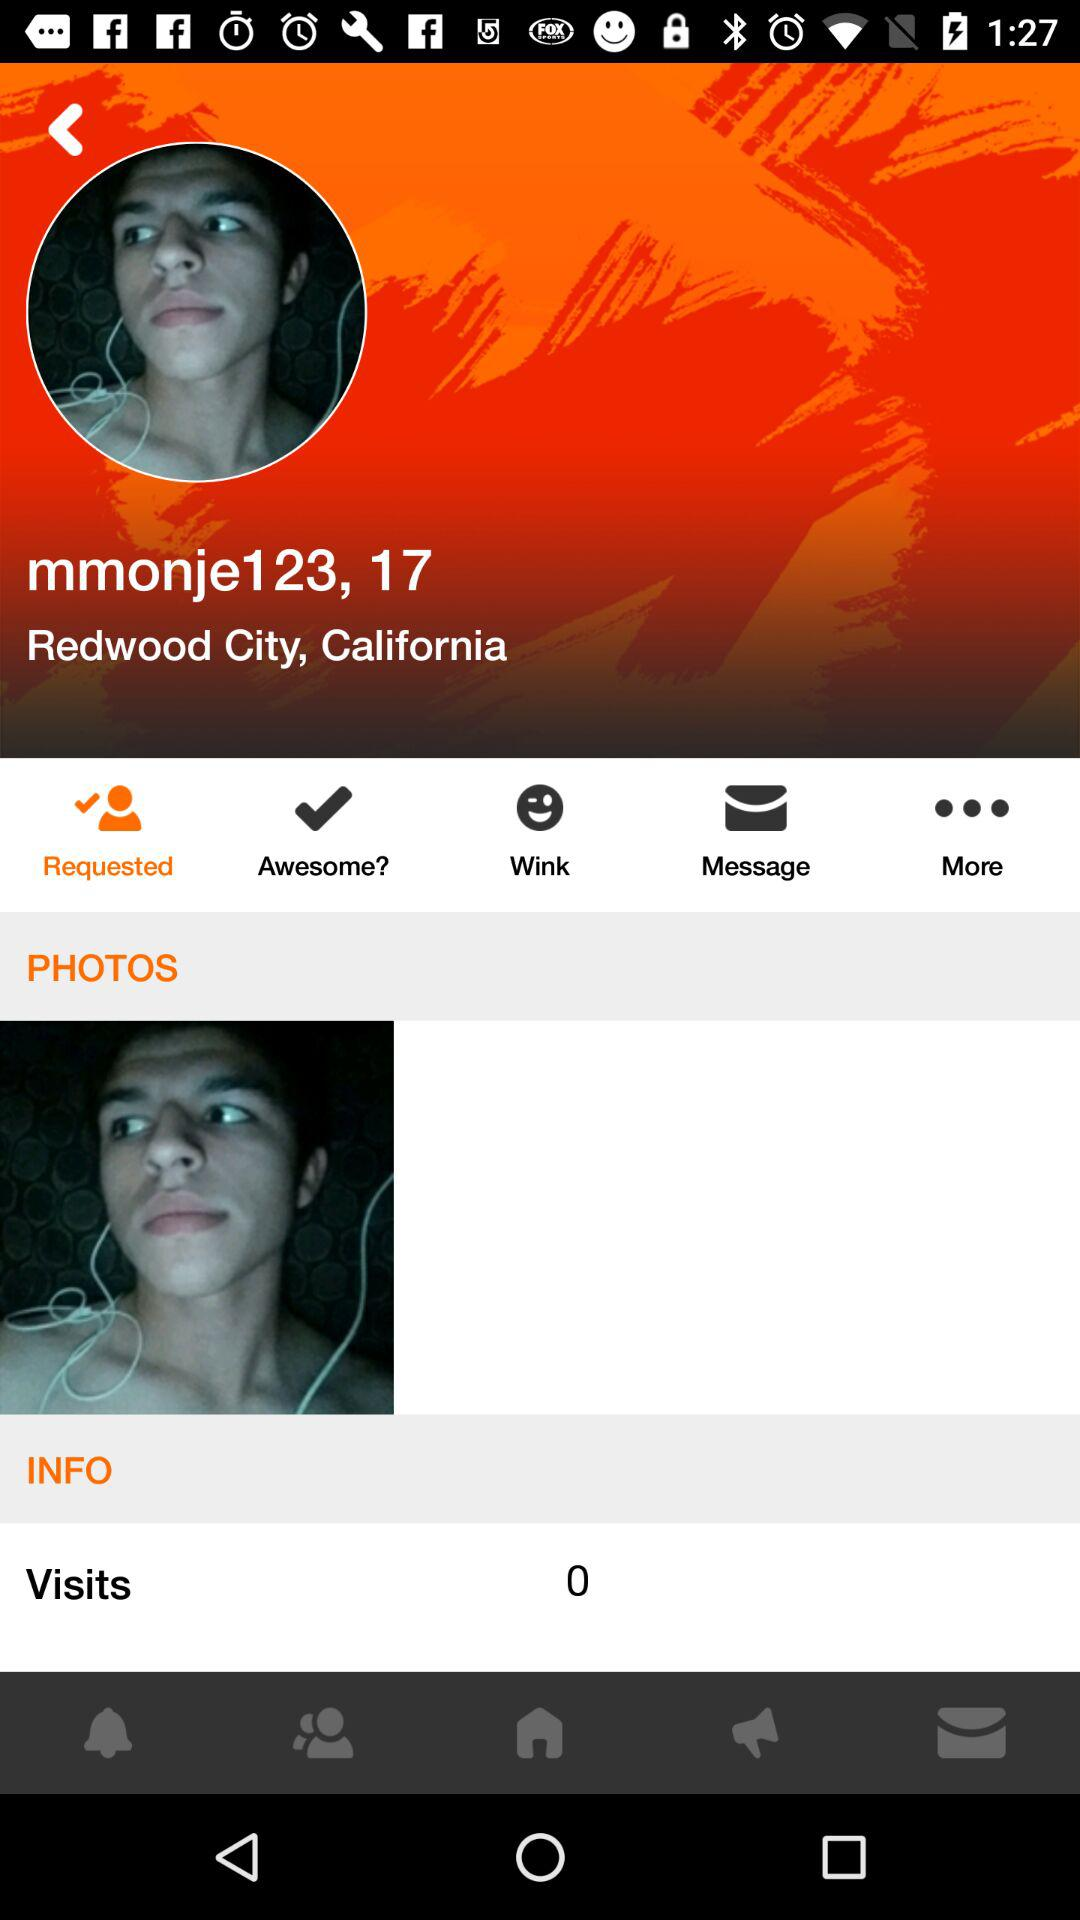What is the age of "mmonje123"? The age of "mmonje123" is 17 years. 